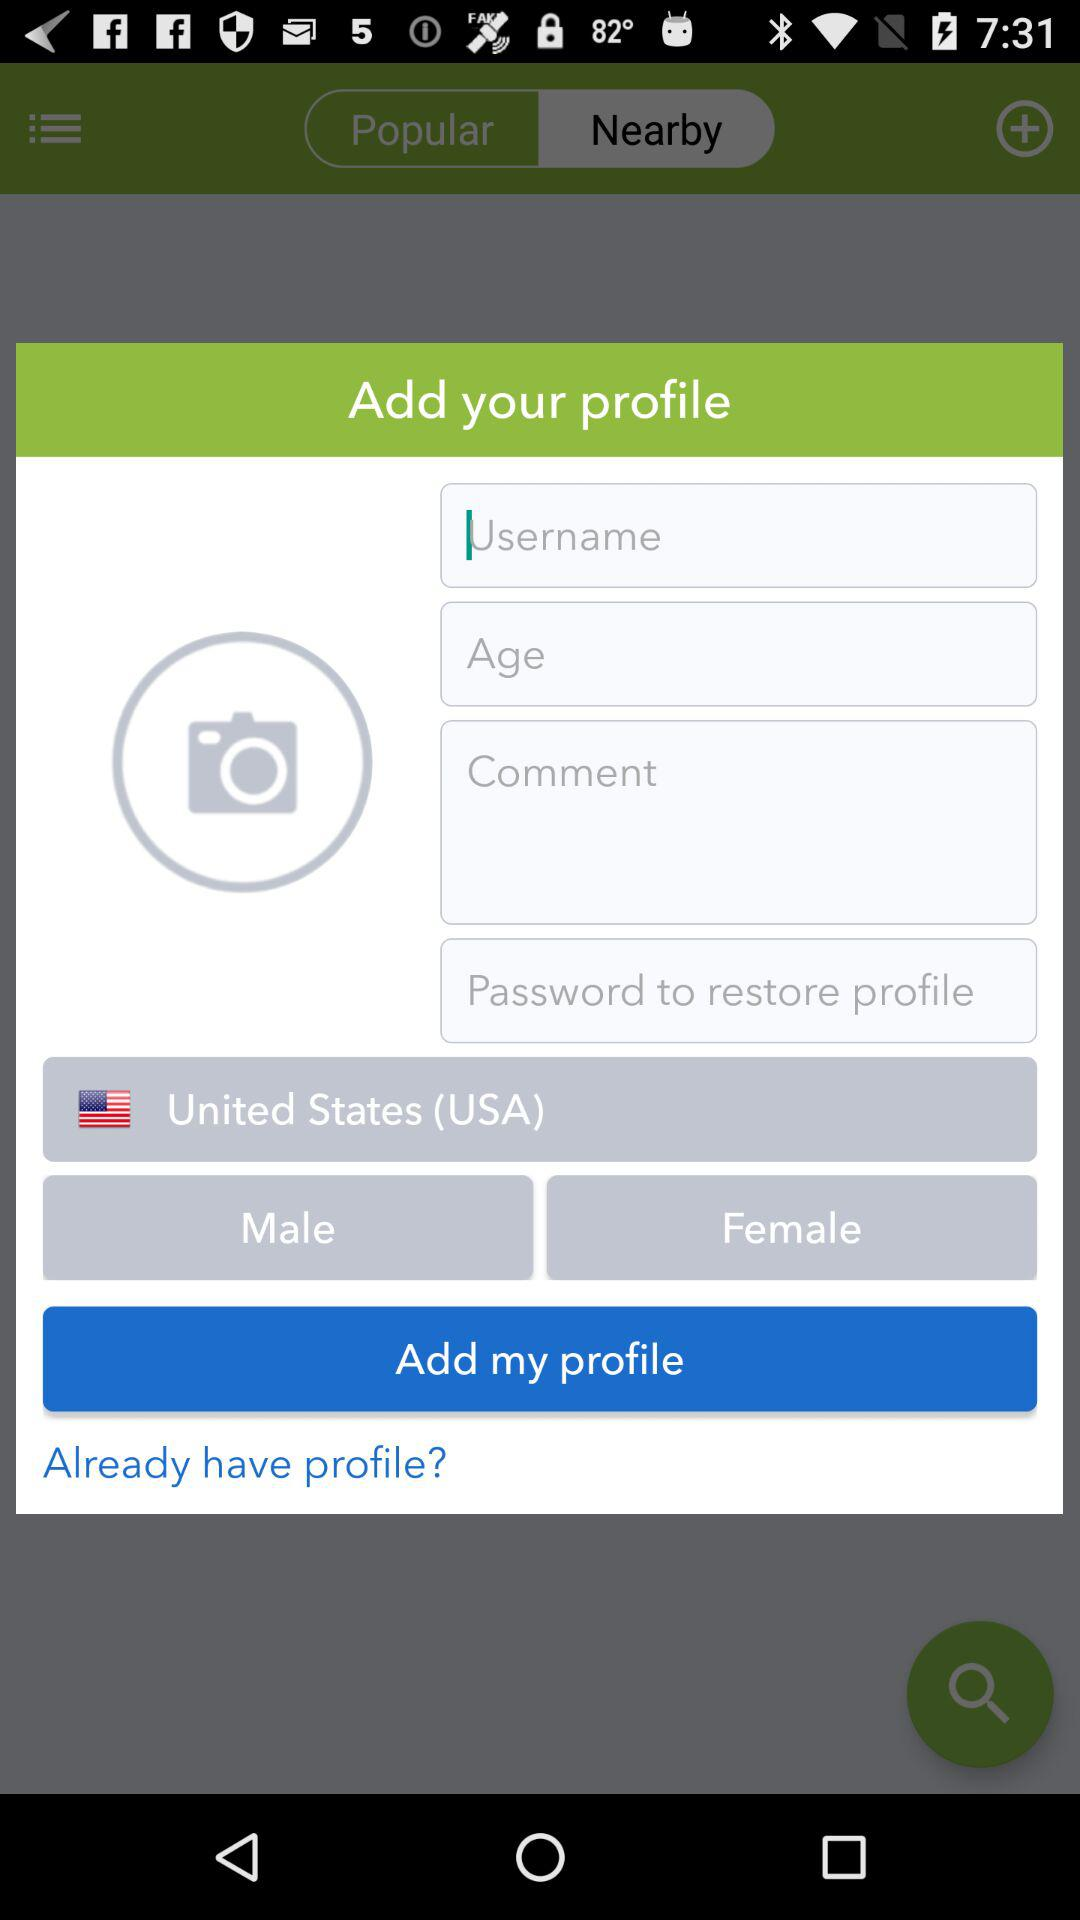What is the gender? The genders are male and female. 